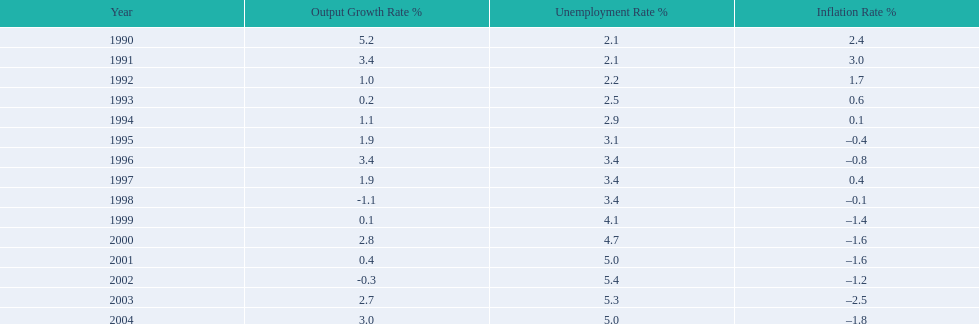In what years, between 1990 and 2004, did japan's unemployment rate reach 5% or higher? 4. Parse the full table. {'header': ['Year', 'Output Growth Rate\xa0%', 'Unemployment Rate\xa0%', 'Inflation Rate\xa0%'], 'rows': [['1990', '5.2', '2.1', '2.4'], ['1991', '3.4', '2.1', '3.0'], ['1992', '1.0', '2.2', '1.7'], ['1993', '0.2', '2.5', '0.6'], ['1994', '1.1', '2.9', '0.1'], ['1995', '1.9', '3.1', '–0.4'], ['1996', '3.4', '3.4', '–0.8'], ['1997', '1.9', '3.4', '0.4'], ['1998', '-1.1', '3.4', '–0.1'], ['1999', '0.1', '4.1', '–1.4'], ['2000', '2.8', '4.7', '–1.6'], ['2001', '0.4', '5.0', '–1.6'], ['2002', '-0.3', '5.4', '–1.2'], ['2003', '2.7', '5.3', '–2.5'], ['2004', '3.0', '5.0', '–1.8']]} 